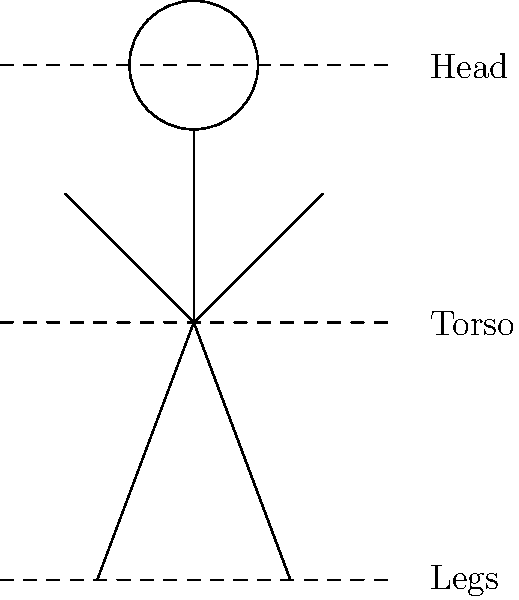In the stick figure sketch above, which proportion rule is being demonstrated for an adult human figure? To answer this question, let's analyze the stick figure sketch step-by-step:

1. The figure is divided into three main sections by dashed lines: head, torso, and legs.

2. These sections appear to be of equal height.

3. In character design and anatomy, there's a common rule for adult human proportions called the "rule of thirds" or "eight heads high" rule.

4. This rule states that an average adult human figure can be divided into eight equal parts, with the head occupying one part, and the rest of the body occupying seven parts.

5. In our sketch, we see three equal sections. If we consider the head as one unit, then the torso and legs each represent about 2-3 units.

6. This simplified division into three equal parts is a basic approximation of the "rule of thirds" used in character design, especially for stylized or cartoon characters.

7. It's important to note that this is a simplified version of human proportions, often used in animation and comics for ease of drawing and to create a more stylized look.

Therefore, the proportion rule being demonstrated is a simplified version of the "rule of thirds" or "eight heads high" rule, adapted for a more stylized character design commonly used in animation and comics.
Answer: Simplified "rule of thirds" for stylized characters 